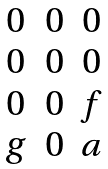<formula> <loc_0><loc_0><loc_500><loc_500>\begin{matrix} 0 & 0 & 0 \\ 0 & 0 & 0 \\ 0 & 0 & f \\ g & 0 & a \end{matrix}</formula> 